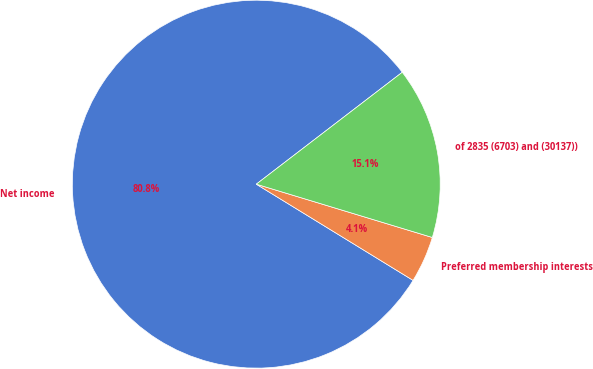Convert chart. <chart><loc_0><loc_0><loc_500><loc_500><pie_chart><fcel>Net income<fcel>Preferred membership interests<fcel>of 2835 (6703) and (30137))<nl><fcel>80.83%<fcel>4.08%<fcel>15.09%<nl></chart> 